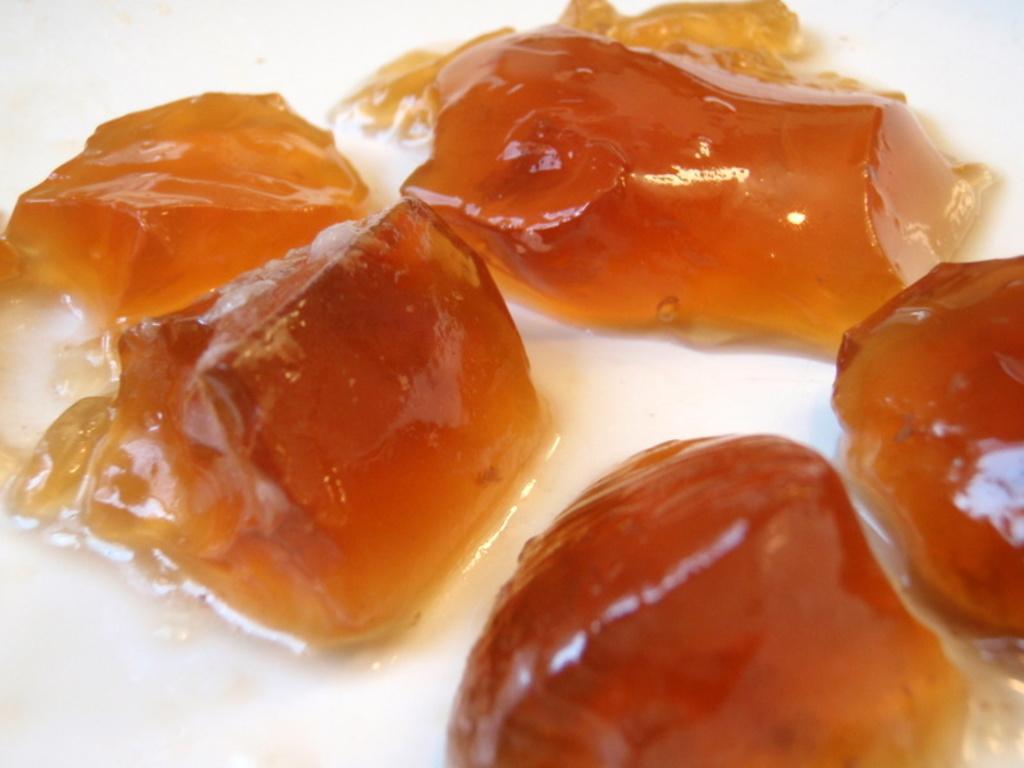In one or two sentences, can you explain what this image depicts? In this image we can see some objects which looks like the food on the white surface. 